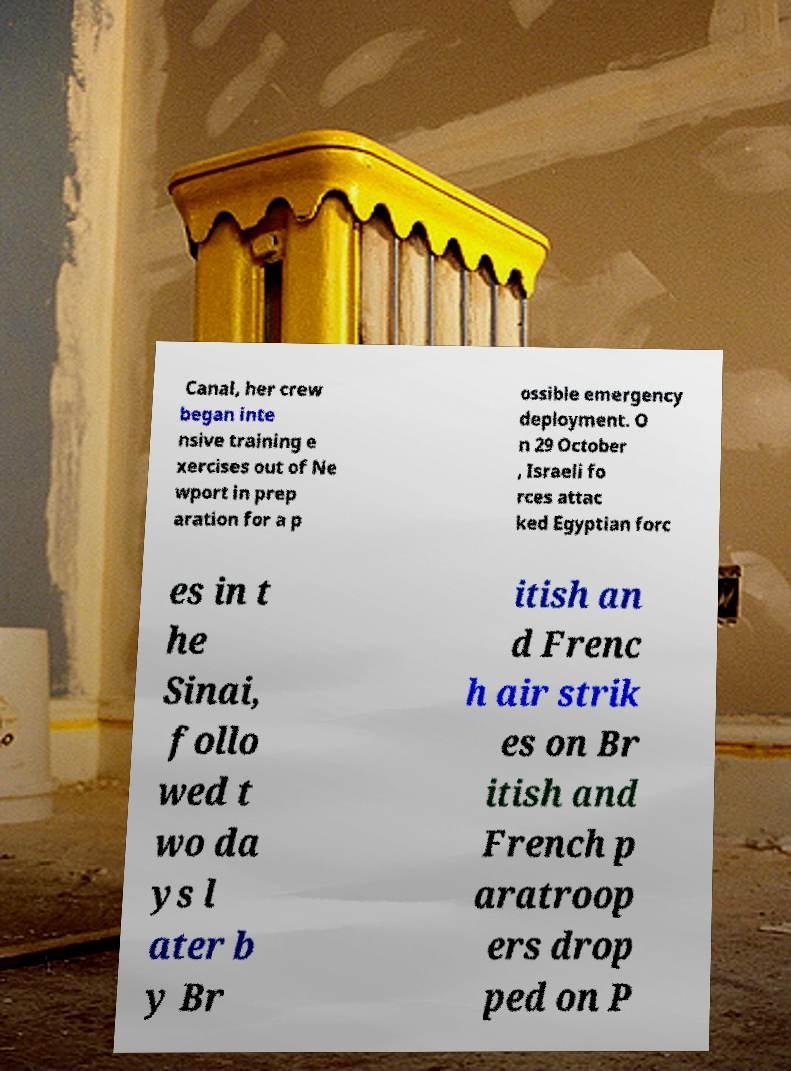Please read and relay the text visible in this image. What does it say? Canal, her crew began inte nsive training e xercises out of Ne wport in prep aration for a p ossible emergency deployment. O n 29 October , Israeli fo rces attac ked Egyptian forc es in t he Sinai, follo wed t wo da ys l ater b y Br itish an d Frenc h air strik es on Br itish and French p aratroop ers drop ped on P 